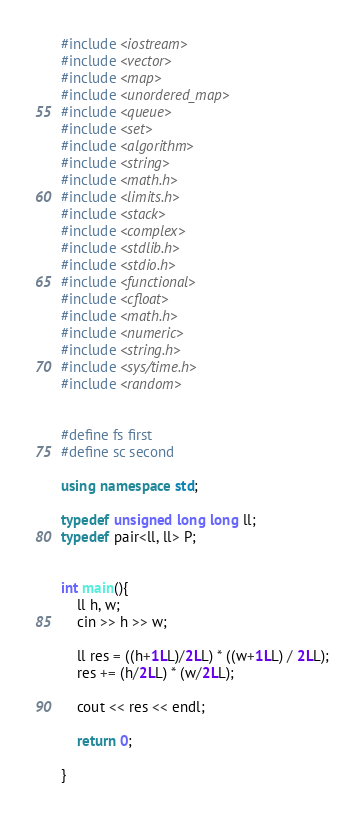Convert code to text. <code><loc_0><loc_0><loc_500><loc_500><_C++_>#include <iostream>
#include <vector>
#include <map>
#include <unordered_map>
#include <queue>
#include <set>
#include <algorithm>
#include <string>
#include <math.h>
#include <limits.h>
#include <stack>
#include <complex>
#include <stdlib.h>
#include <stdio.h>
#include <functional>
#include <cfloat>
#include <math.h>
#include <numeric>
#include <string.h>
#include <sys/time.h>
#include <random>


#define fs first
#define sc second

using namespace std;

typedef unsigned long long ll;
typedef pair<ll, ll> P;


int main(){
    ll h, w;
    cin >> h >> w;

    ll res = ((h+1LL)/2LL) * ((w+1LL) / 2LL);
    res += (h/2LL) * (w/2LL);

    cout << res << endl;

    return 0;

}
</code> 